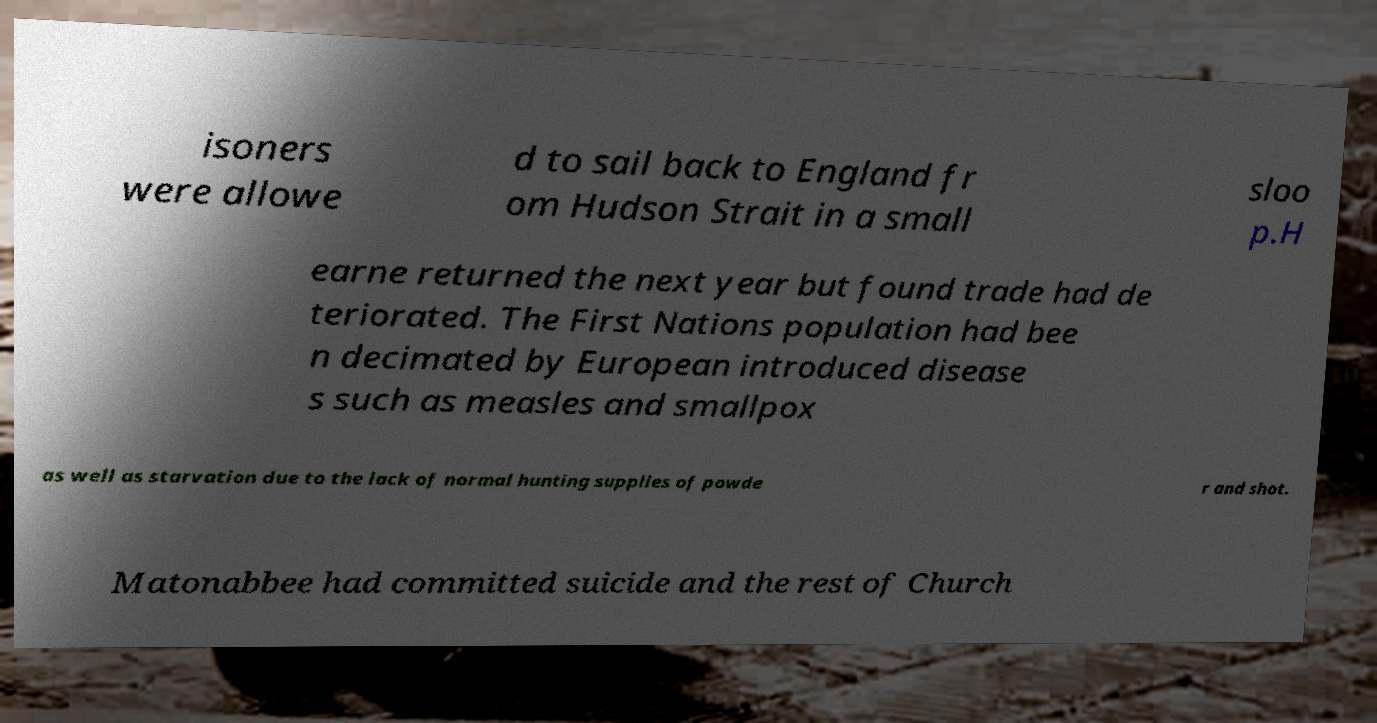Could you extract and type out the text from this image? isoners were allowe d to sail back to England fr om Hudson Strait in a small sloo p.H earne returned the next year but found trade had de teriorated. The First Nations population had bee n decimated by European introduced disease s such as measles and smallpox as well as starvation due to the lack of normal hunting supplies of powde r and shot. Matonabbee had committed suicide and the rest of Church 